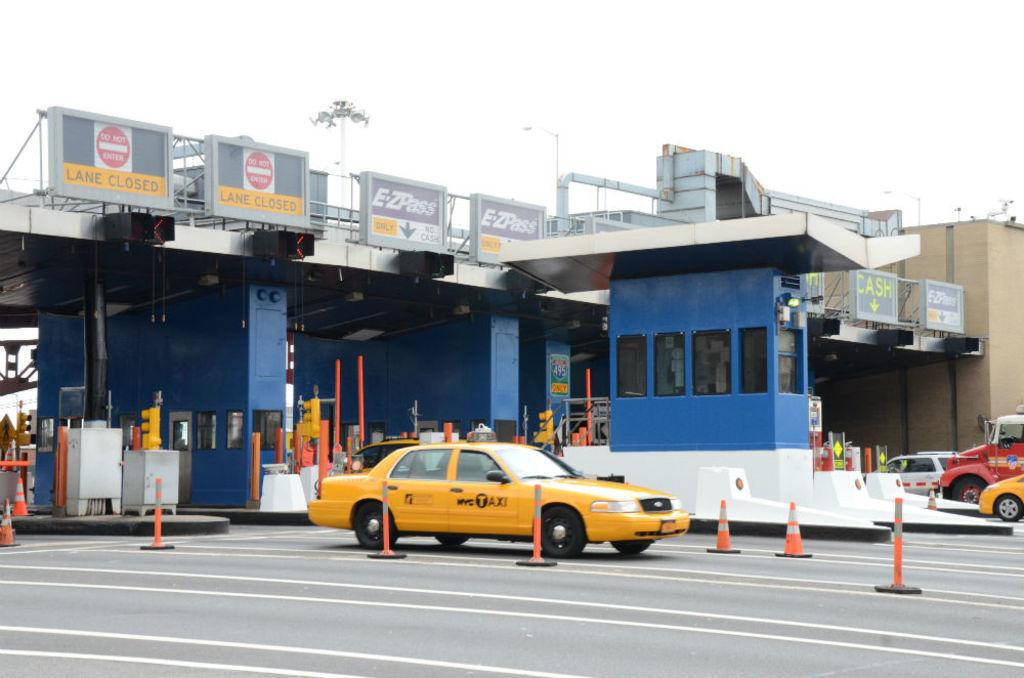<image>
Offer a succinct explanation of the picture presented. A yellow cab from the company NYC Taxi 